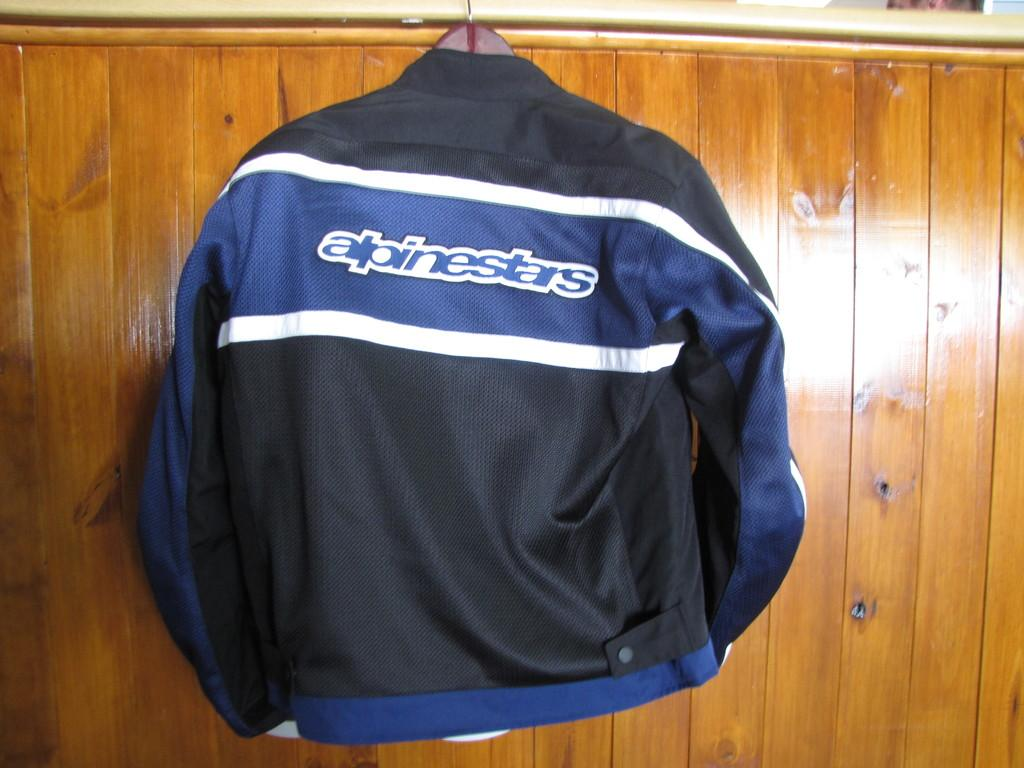Provide a one-sentence caption for the provided image. Alpinestars is displayed on the back of this jacket. 